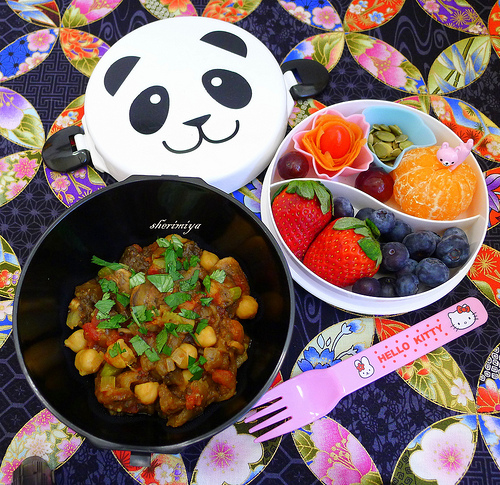<image>
Can you confirm if the panda is on the fork? No. The panda is not positioned on the fork. They may be near each other, but the panda is not supported by or resting on top of the fork. 